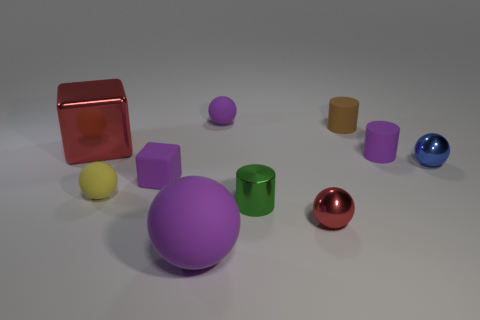Subtract all tiny shiny balls. How many balls are left? 3 Subtract 2 balls. How many balls are left? 3 Subtract all blocks. How many objects are left? 8 Subtract all blue balls. How many balls are left? 4 Subtract all purple blocks. Subtract all brown cylinders. How many blocks are left? 1 Subtract all blue cylinders. How many red cubes are left? 1 Subtract all tiny rubber cubes. Subtract all tiny red shiny objects. How many objects are left? 8 Add 8 blue metallic spheres. How many blue metallic spheres are left? 9 Add 9 cyan metallic balls. How many cyan metallic balls exist? 9 Subtract 0 gray spheres. How many objects are left? 10 